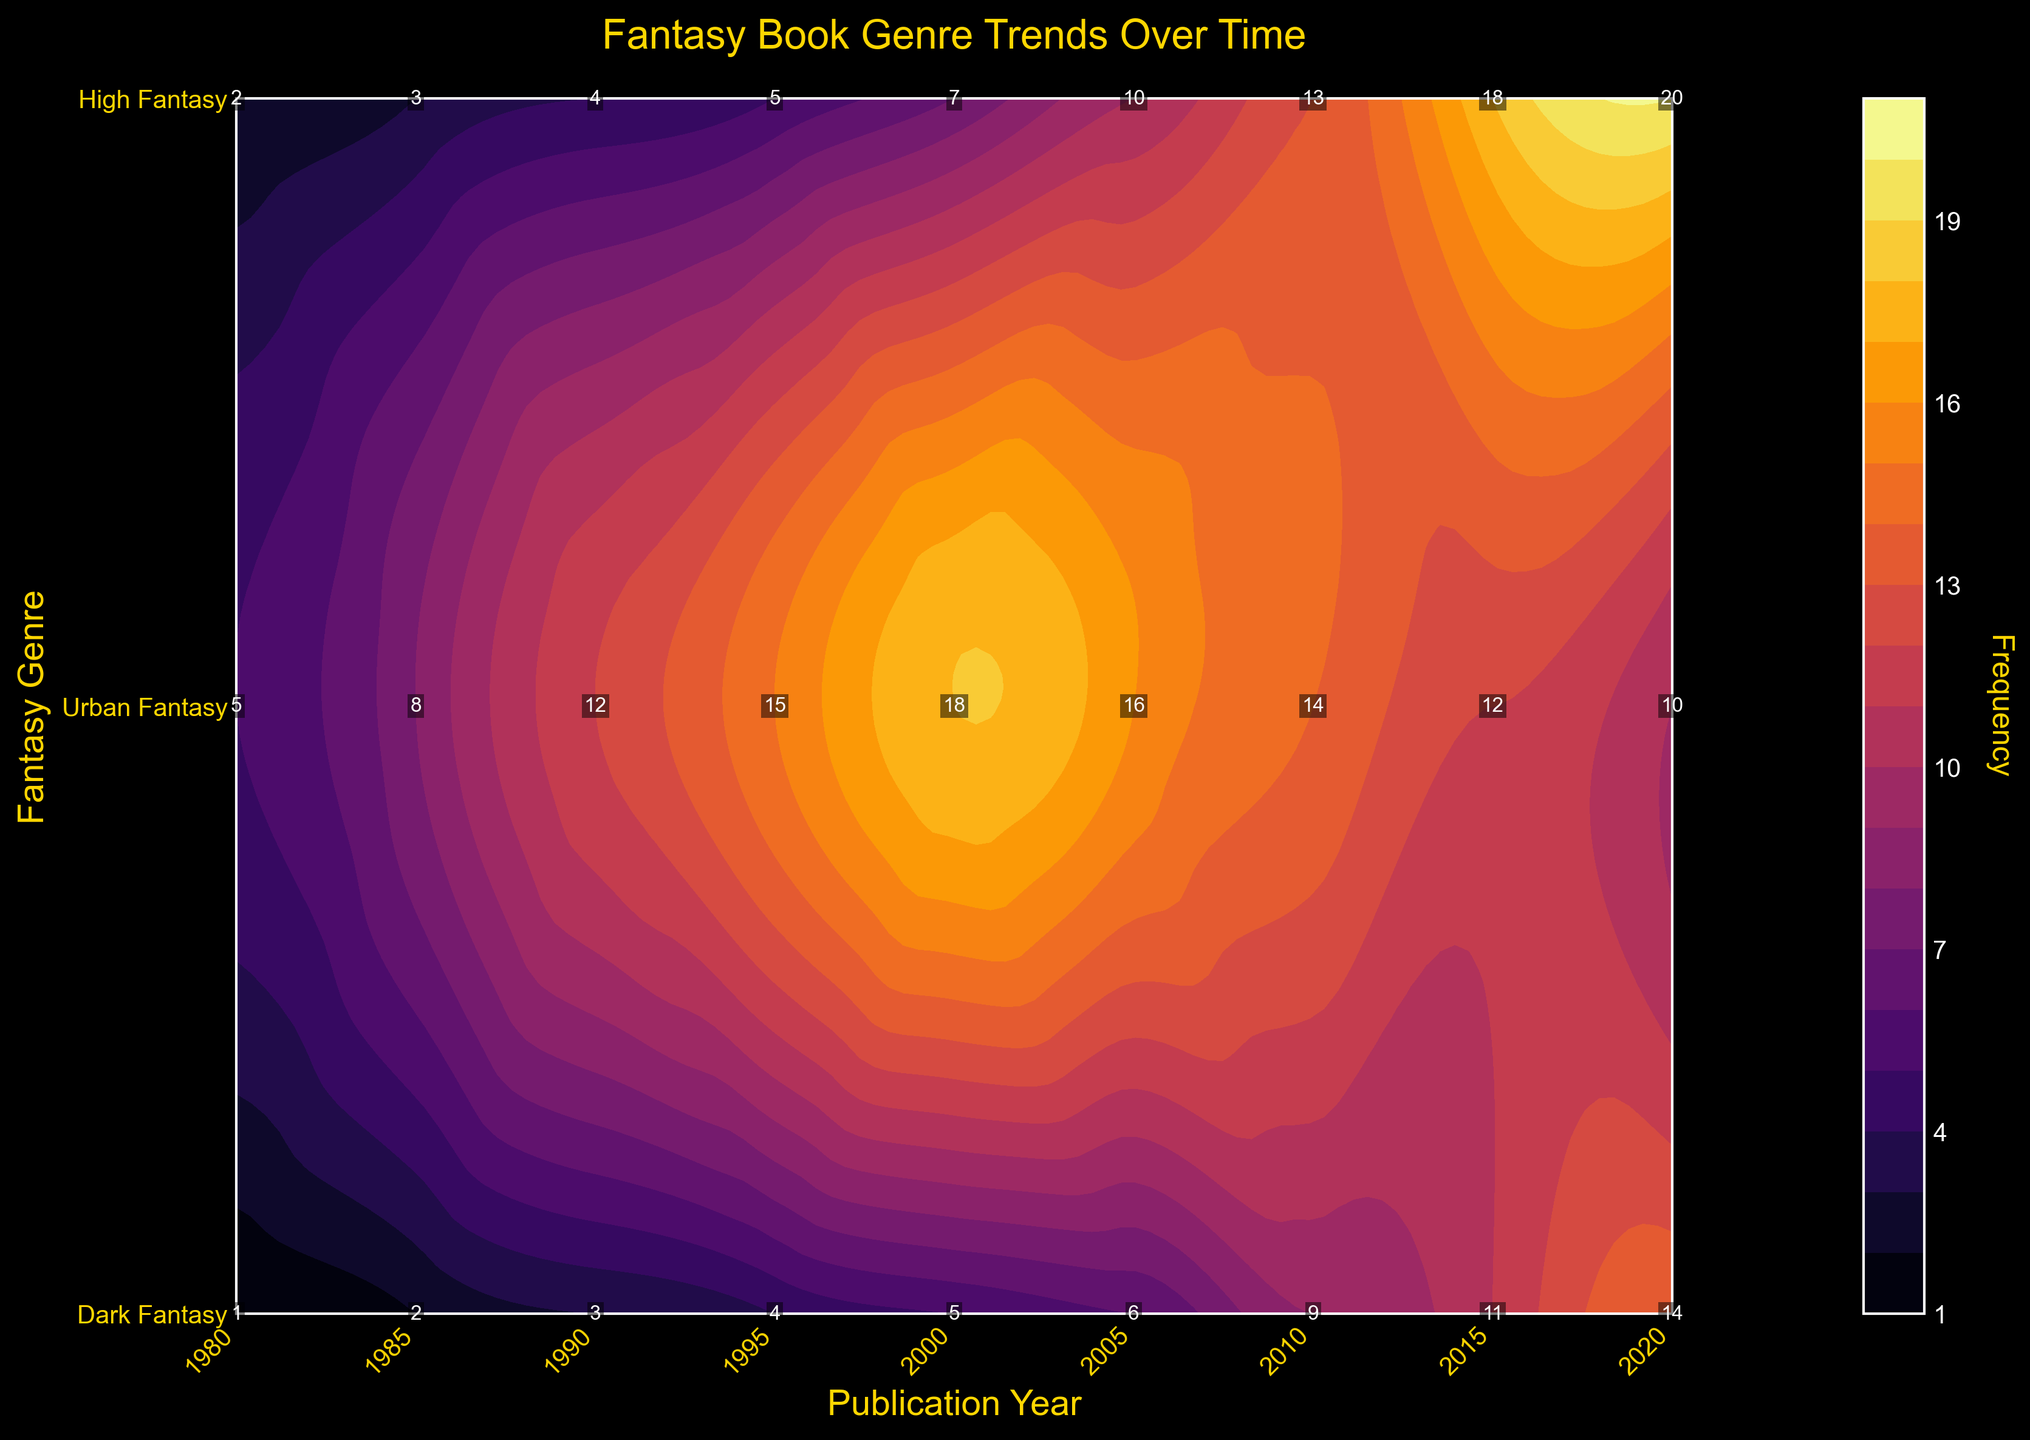What is the title of the figure? The title is typically located at the top of the figure and is set to provide a summary of what the plot represents. In this case, the title is "Fantasy Book Genre Trends Over Time."
Answer: Fantasy Book Genre Trends Over Time Which genre has the label with the highest frequency in the year 2020? The labels in the plot show the frequency for each genre at specific years. By looking at the year 2020, the genre with the highest frequency label is Urban Fantasy, marked with a frequency of 20.
Answer: Urban Fantasy What colors are used to represent the contour regions in the plot? The contour regions in the plot are represented using a color gradient, with darker colors indicating lower frequencies and brighter colors indicating higher frequencies. The color map used is 'inferno', which transitions from dark purple to yellow.
Answer: Dark purple to yellow Between which years did High Fantasy have its peak frequency? By examining the contour plot for High Fantasy (located at the top row), you can identify that the highest frequency label for High Fantasy is during the year 2000.
Answer: 2000 How does the frequency of Urban Fantasy in 2005 compare to its frequency in 2015? Comparing the labels for Urban Fantasy (middle row), the frequency in 2005 is 10 and in 2015 it is 18. Therefore, the frequency increased from 2005 to 2015.
Answer: Increased What are the y-axis labels in the plot? The y-axis labels are custom-defined and represent the different fantasy genres. They are, from bottom to top: Dark Fantasy, Urban Fantasy, High Fantasy.
Answer: Dark Fantasy, Urban Fantasy, High Fantasy By how much did the frequency of Dark Fantasy increase from 1990 to 2020? Dark Fantasy's frequency in 1990 is 3 and in 2020 it is 14. The increase is calculated by subtracting 3 from 14, resulting in an increase of 11.
Answer: 11 Which genre shows a decreasing trend in frequency from 2000 to 2020? Looking at the frequency labels for each genre from 2000 to 2020, High Fantasy (located at the top row) shows a decrease, with frequencies of 18 in 2000 and 10 in 2020.
Answer: High Fantasy What is the average frequency of High Fantasy over the given years? To calculate the average frequency of High Fantasy, add up all the frequencies for this genre (5, 8, 12, 15, 18, 16, 14, 12, 10) and divide by the number of data points (9): (5+8+12+15+18+16+14+12+10)/9 = 12.2
Answer: 12.2 